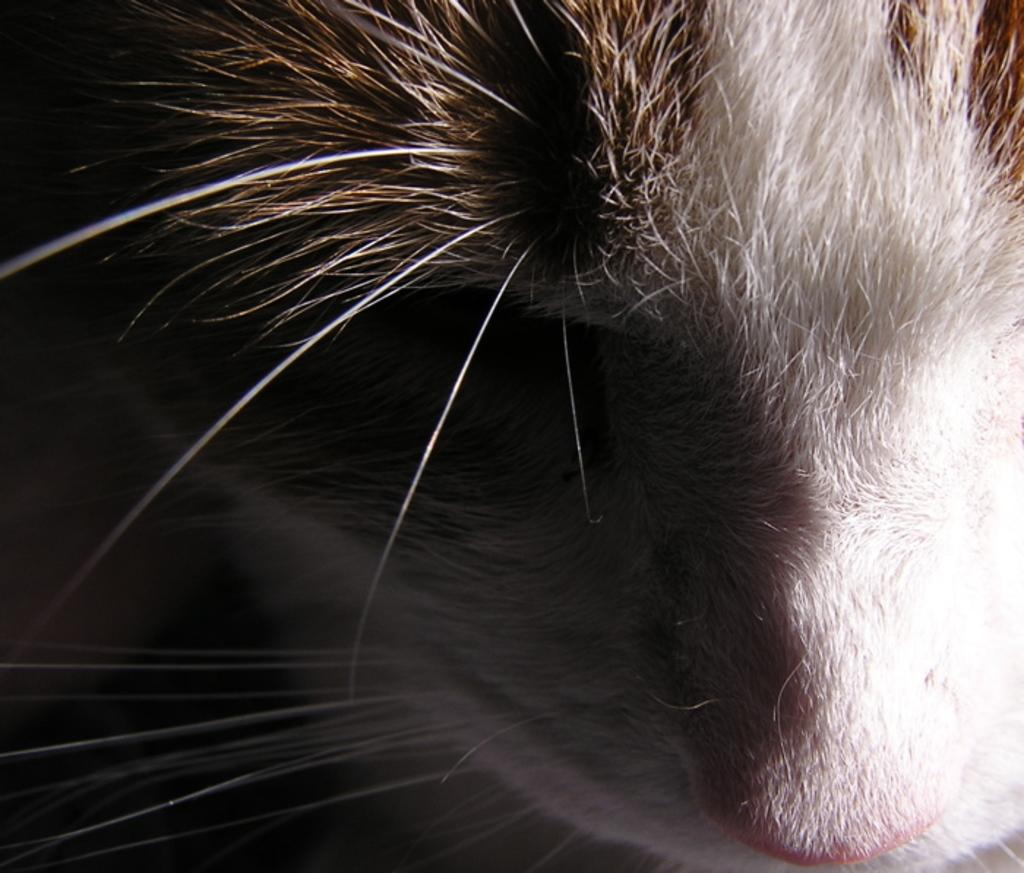What type of living creature can be seen in the image? There is an animal in the image. What type of faucet is being used to water the plants in the image? There is no faucet or plants present in the image; it only features an animal. 